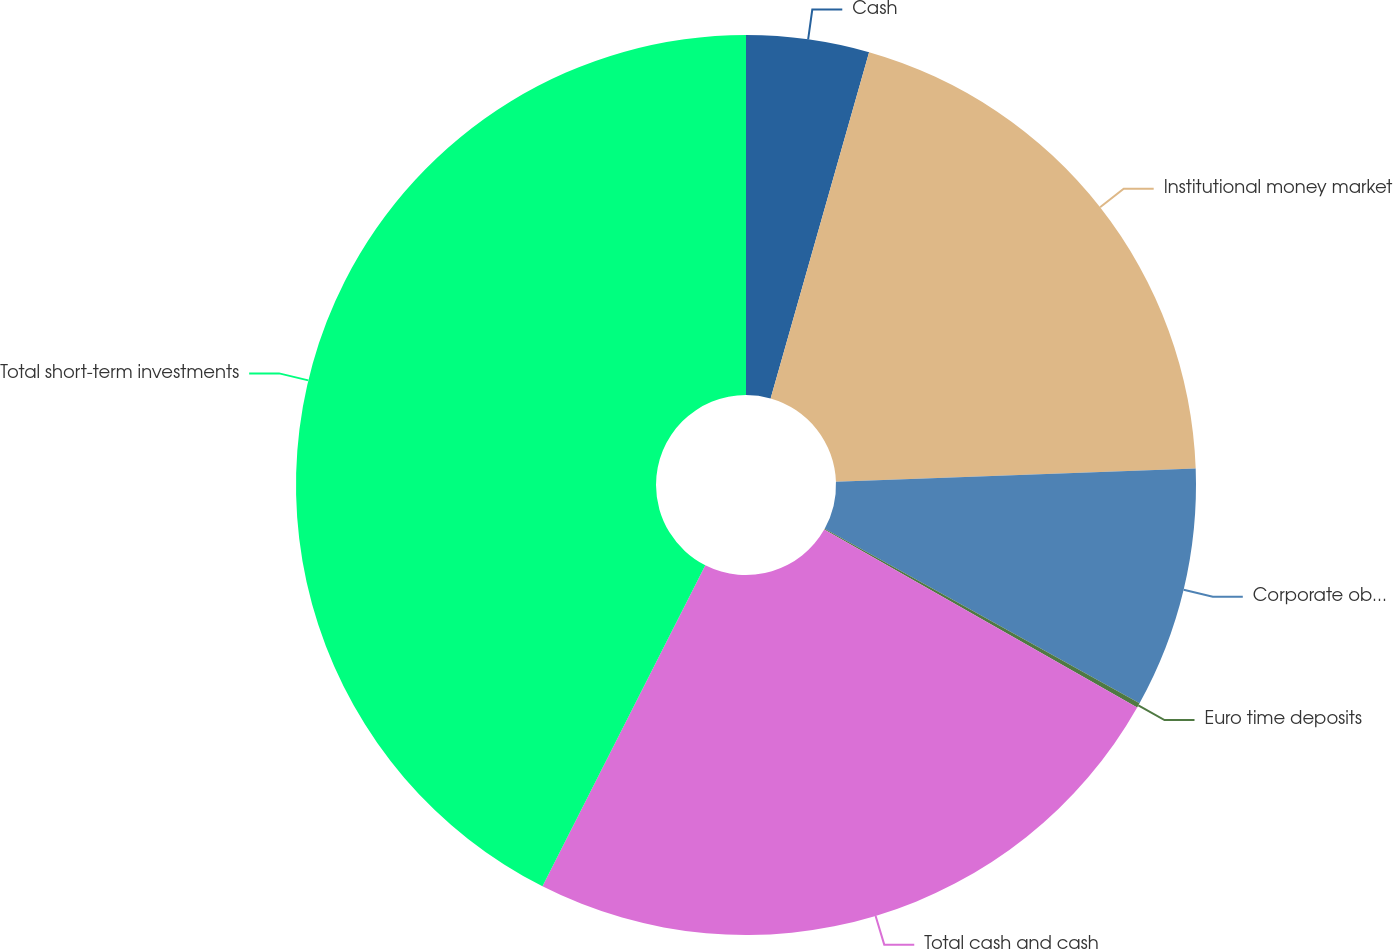Convert chart to OTSL. <chart><loc_0><loc_0><loc_500><loc_500><pie_chart><fcel>Cash<fcel>Institutional money market<fcel>Corporate obligations<fcel>Euro time deposits<fcel>Total cash and cash<fcel>Total short-term investments<nl><fcel>4.41%<fcel>20.01%<fcel>8.64%<fcel>0.17%<fcel>24.24%<fcel>42.53%<nl></chart> 